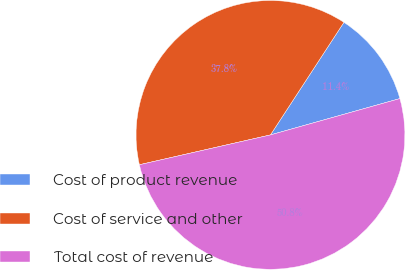<chart> <loc_0><loc_0><loc_500><loc_500><pie_chart><fcel>Cost of product revenue<fcel>Cost of service and other<fcel>Total cost of revenue<nl><fcel>11.44%<fcel>37.76%<fcel>50.79%<nl></chart> 